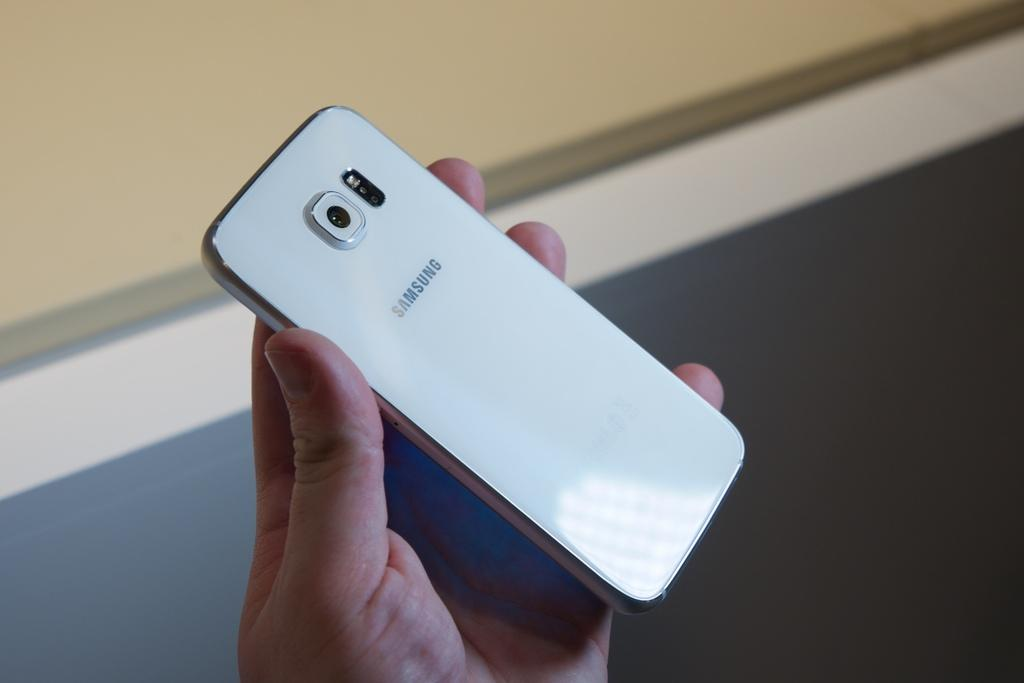<image>
Summarize the visual content of the image. A hand holding up a white Samsung cell phone. 